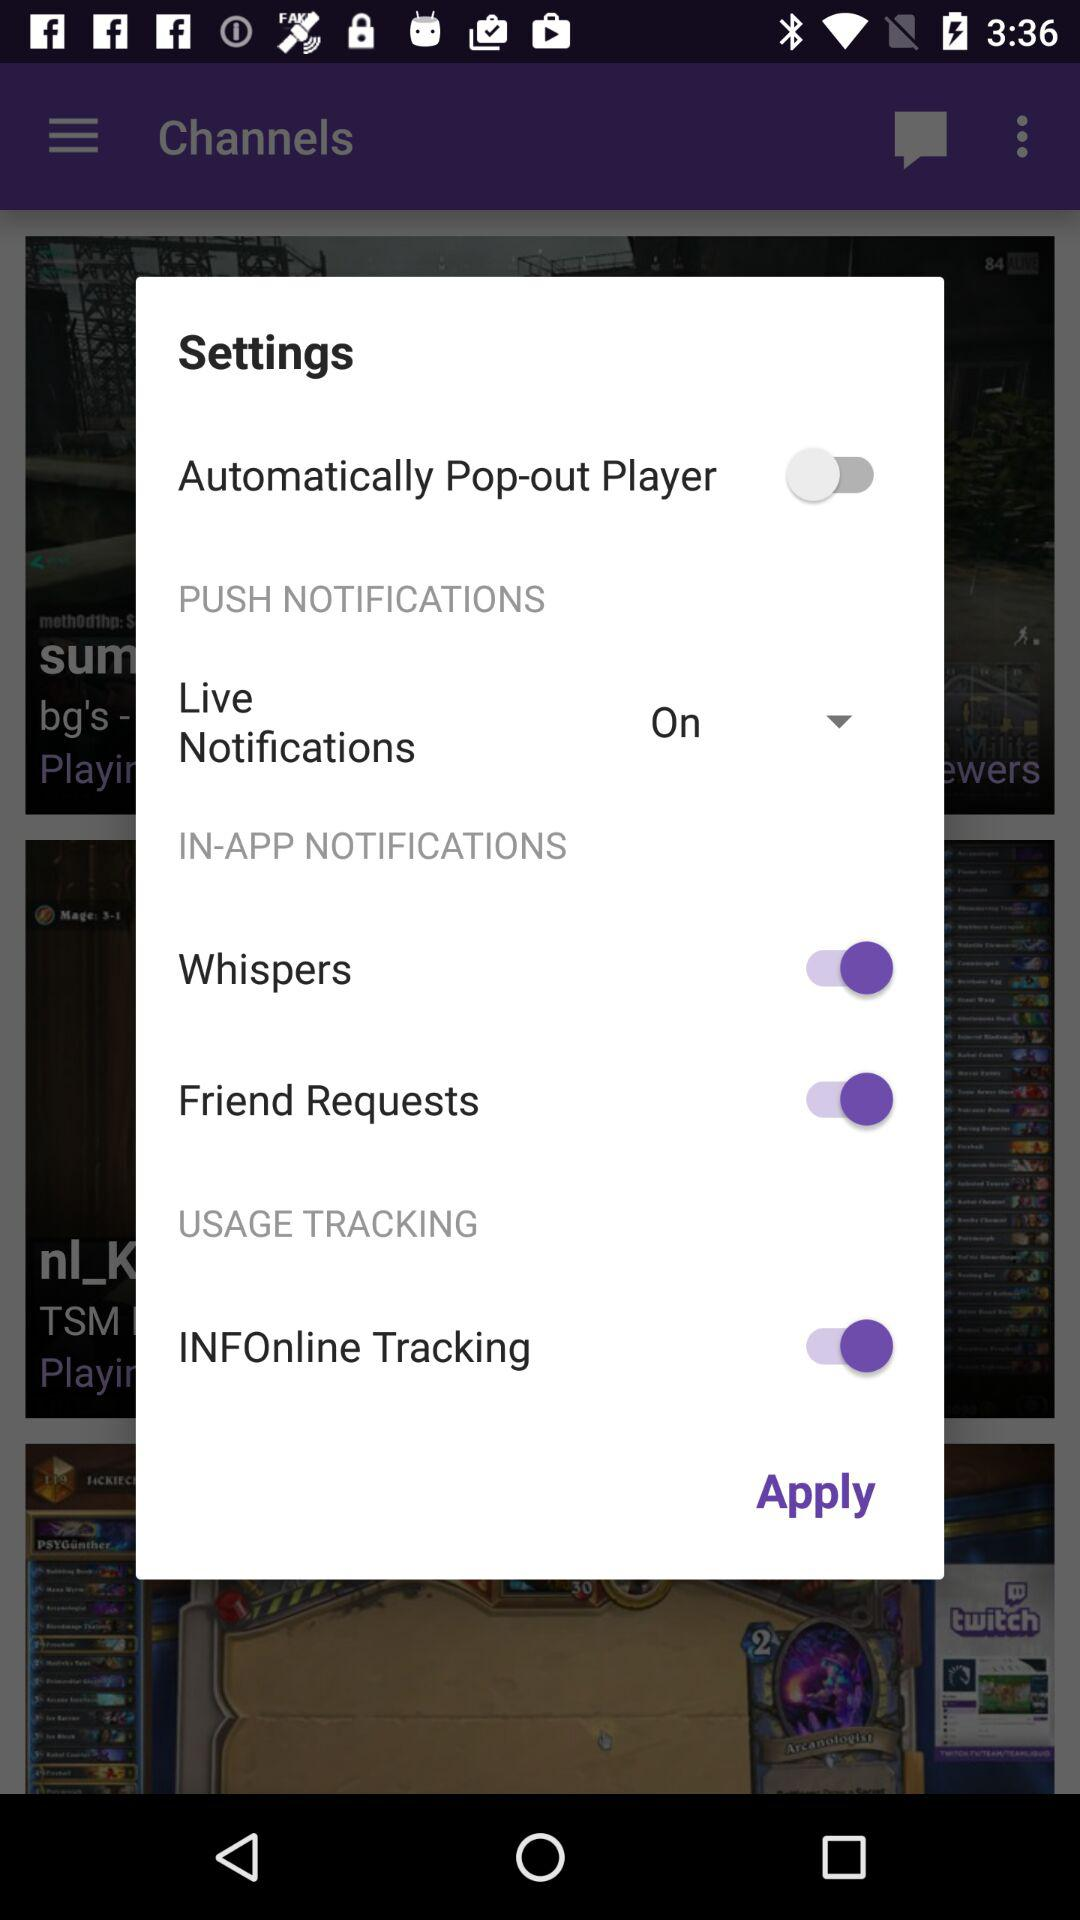Which setting has been disabled? The setting is "Automatically Pop-out Player". 